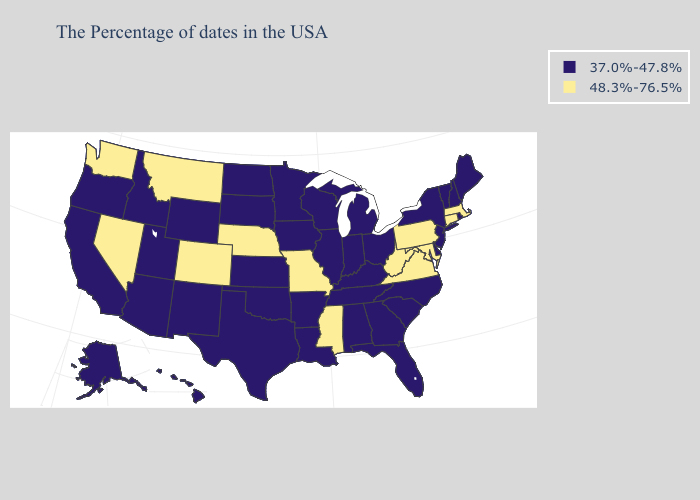What is the value of Pennsylvania?
Give a very brief answer. 48.3%-76.5%. What is the value of Tennessee?
Be succinct. 37.0%-47.8%. Does Florida have a lower value than South Carolina?
Give a very brief answer. No. Is the legend a continuous bar?
Short answer required. No. Is the legend a continuous bar?
Be succinct. No. What is the highest value in states that border Louisiana?
Quick response, please. 48.3%-76.5%. What is the value of South Dakota?
Write a very short answer. 37.0%-47.8%. Which states hav the highest value in the MidWest?
Give a very brief answer. Missouri, Nebraska. What is the highest value in the USA?
Short answer required. 48.3%-76.5%. Which states have the highest value in the USA?
Short answer required. Massachusetts, Connecticut, Maryland, Pennsylvania, Virginia, West Virginia, Mississippi, Missouri, Nebraska, Colorado, Montana, Nevada, Washington. Does New Mexico have a higher value than West Virginia?
Quick response, please. No. What is the lowest value in states that border Virginia?
Write a very short answer. 37.0%-47.8%. Does the map have missing data?
Quick response, please. No. Name the states that have a value in the range 37.0%-47.8%?
Write a very short answer. Maine, Rhode Island, New Hampshire, Vermont, New York, New Jersey, Delaware, North Carolina, South Carolina, Ohio, Florida, Georgia, Michigan, Kentucky, Indiana, Alabama, Tennessee, Wisconsin, Illinois, Louisiana, Arkansas, Minnesota, Iowa, Kansas, Oklahoma, Texas, South Dakota, North Dakota, Wyoming, New Mexico, Utah, Arizona, Idaho, California, Oregon, Alaska, Hawaii. Name the states that have a value in the range 37.0%-47.8%?
Quick response, please. Maine, Rhode Island, New Hampshire, Vermont, New York, New Jersey, Delaware, North Carolina, South Carolina, Ohio, Florida, Georgia, Michigan, Kentucky, Indiana, Alabama, Tennessee, Wisconsin, Illinois, Louisiana, Arkansas, Minnesota, Iowa, Kansas, Oklahoma, Texas, South Dakota, North Dakota, Wyoming, New Mexico, Utah, Arizona, Idaho, California, Oregon, Alaska, Hawaii. 